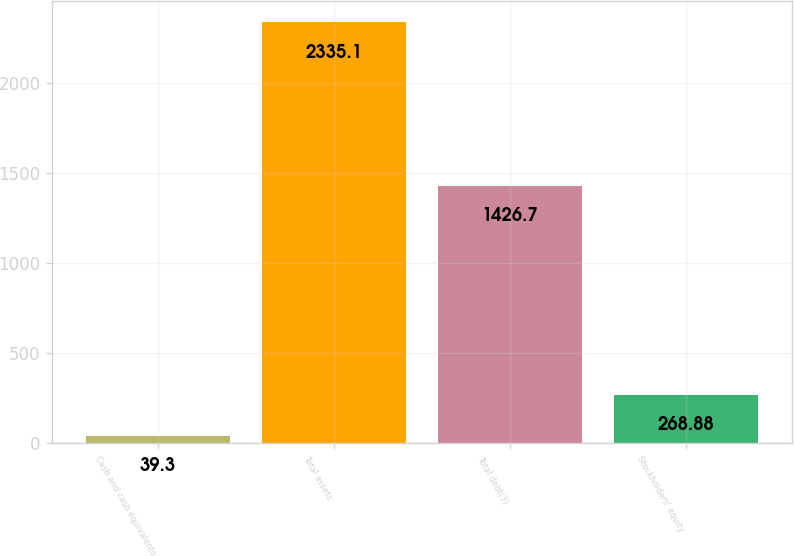Convert chart. <chart><loc_0><loc_0><loc_500><loc_500><bar_chart><fcel>Cash and cash equivalents<fcel>Total assets<fcel>Total debt(3)<fcel>Stockholders' equity<nl><fcel>39.3<fcel>2335.1<fcel>1426.7<fcel>268.88<nl></chart> 